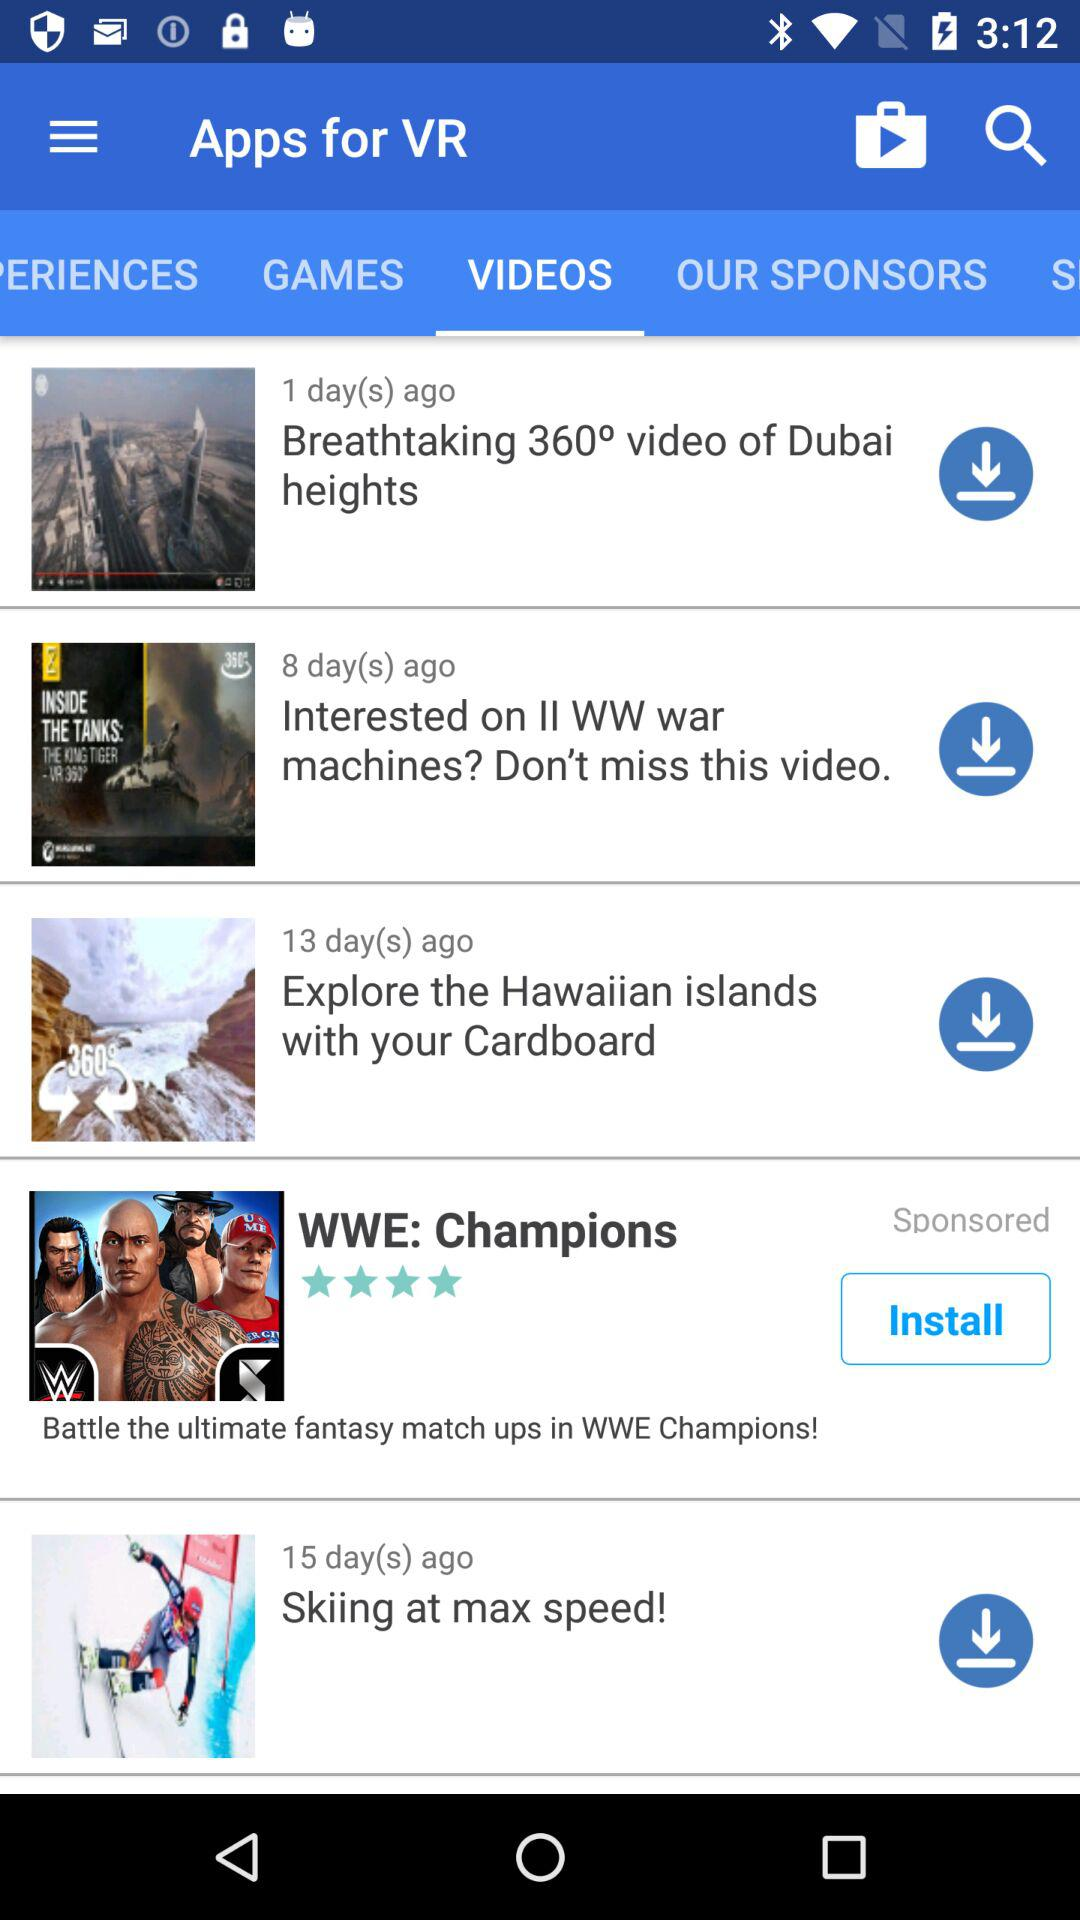What's the application name in the advertisement? The application name in the advertisement is "WWE: Champions". 